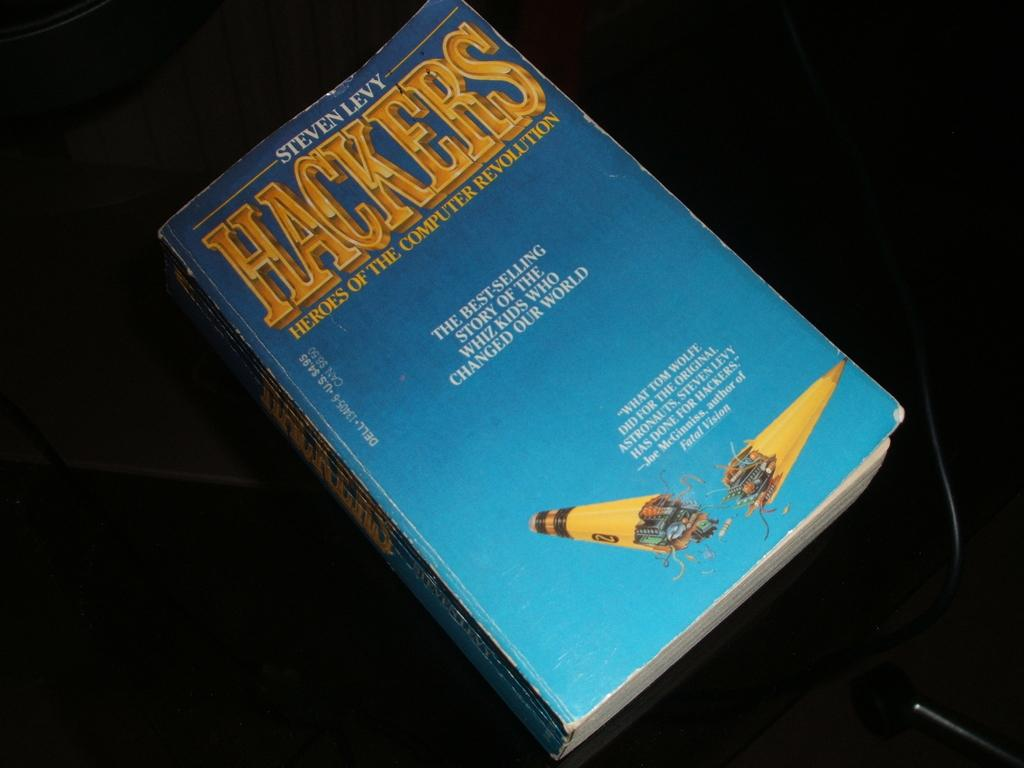<image>
Write a terse but informative summary of the picture. book with a blue cover called hackers with yellow writing 